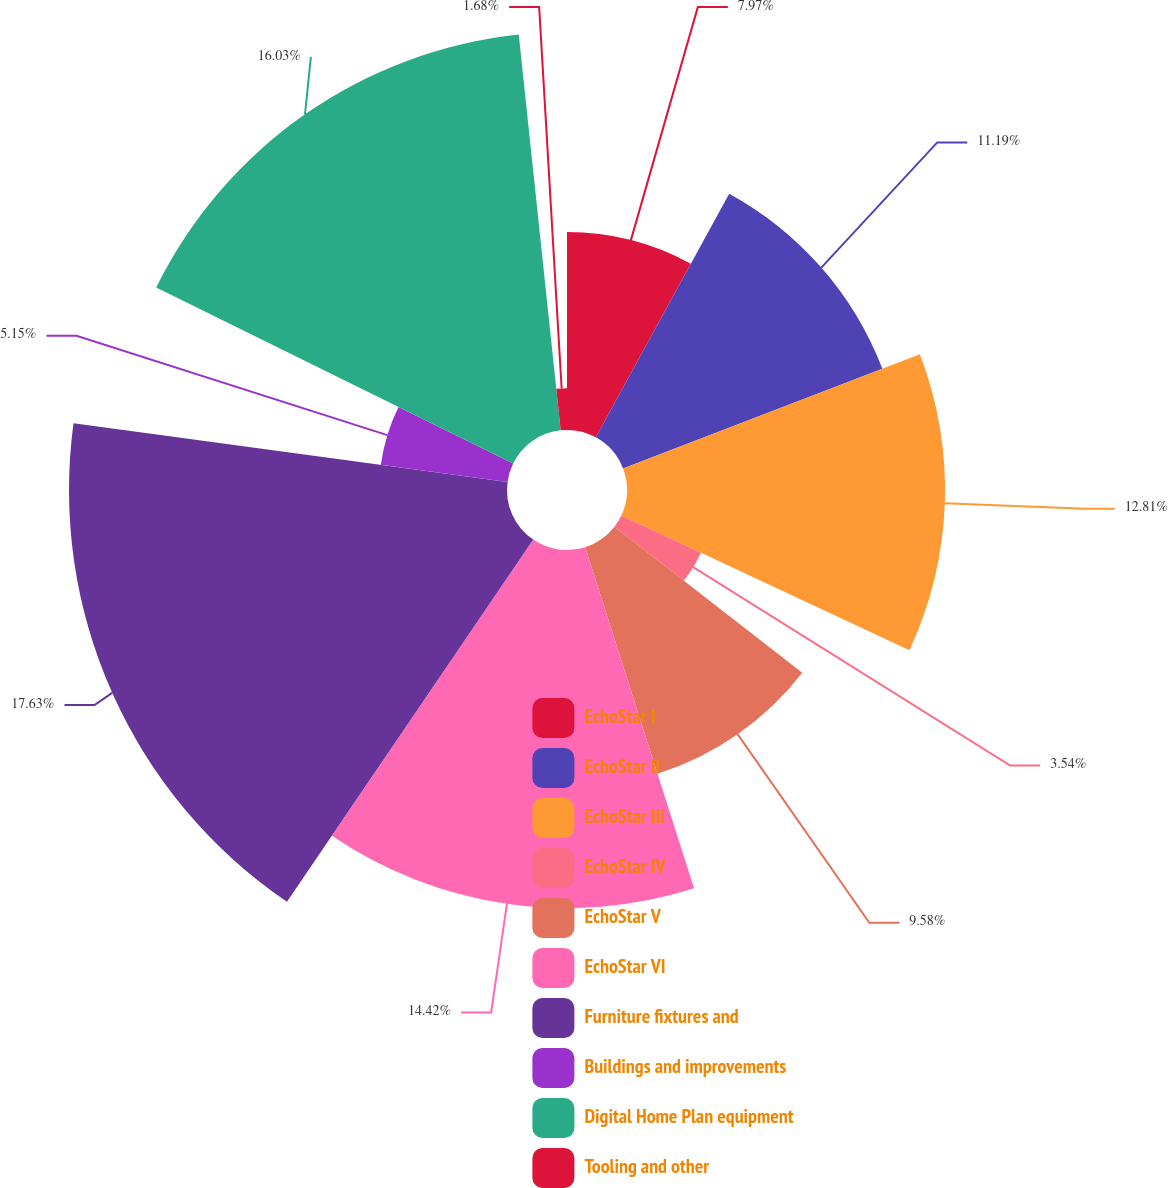<chart> <loc_0><loc_0><loc_500><loc_500><pie_chart><fcel>EchoStar I<fcel>EchoStar II<fcel>EchoStar III<fcel>EchoStar IV<fcel>EchoStar V<fcel>EchoStar VI<fcel>Furniture fixtures and<fcel>Buildings and improvements<fcel>Digital Home Plan equipment<fcel>Tooling and other<nl><fcel>7.97%<fcel>11.19%<fcel>12.81%<fcel>3.54%<fcel>9.58%<fcel>14.42%<fcel>17.64%<fcel>5.15%<fcel>16.03%<fcel>1.68%<nl></chart> 